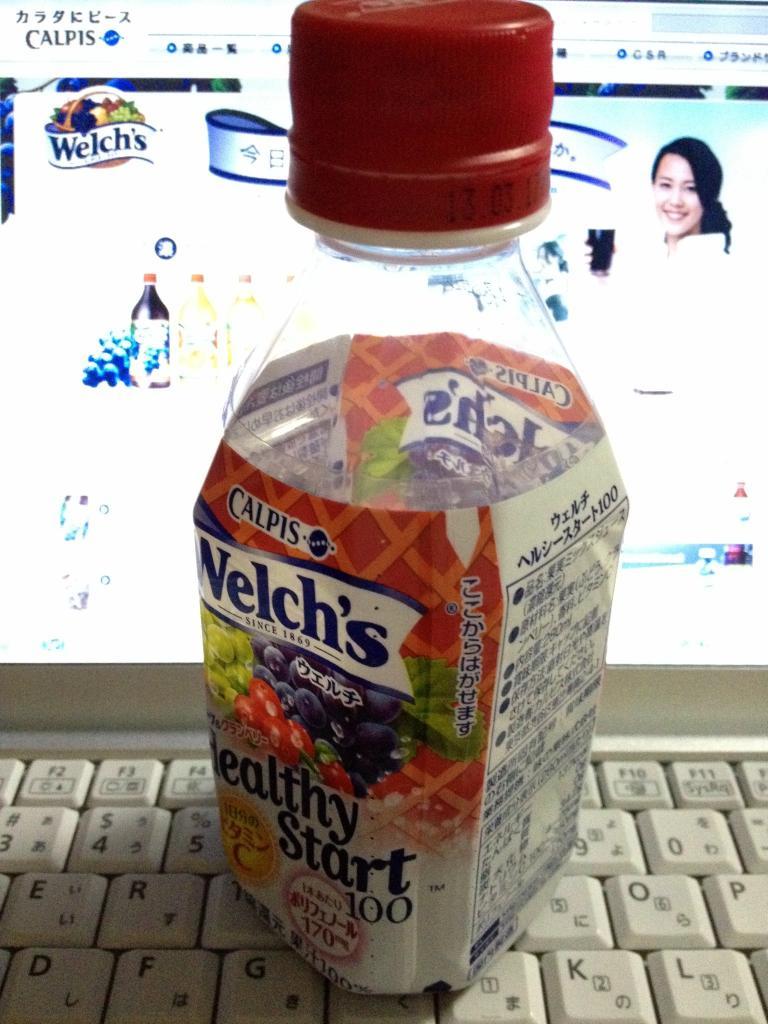What major brand does the bottle belong to?
Keep it short and to the point. Welch's. What number follows healthy start?
Ensure brevity in your answer.  100. 